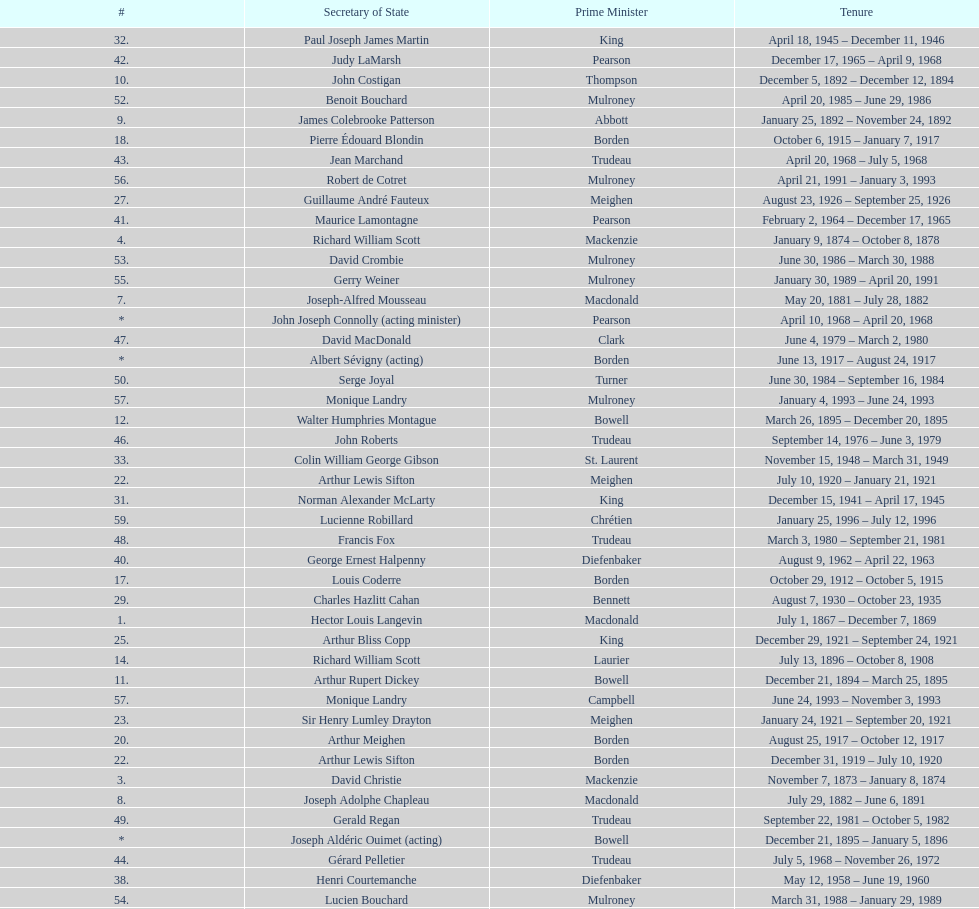How many secretaries of state had the last name bouchard? 2. 